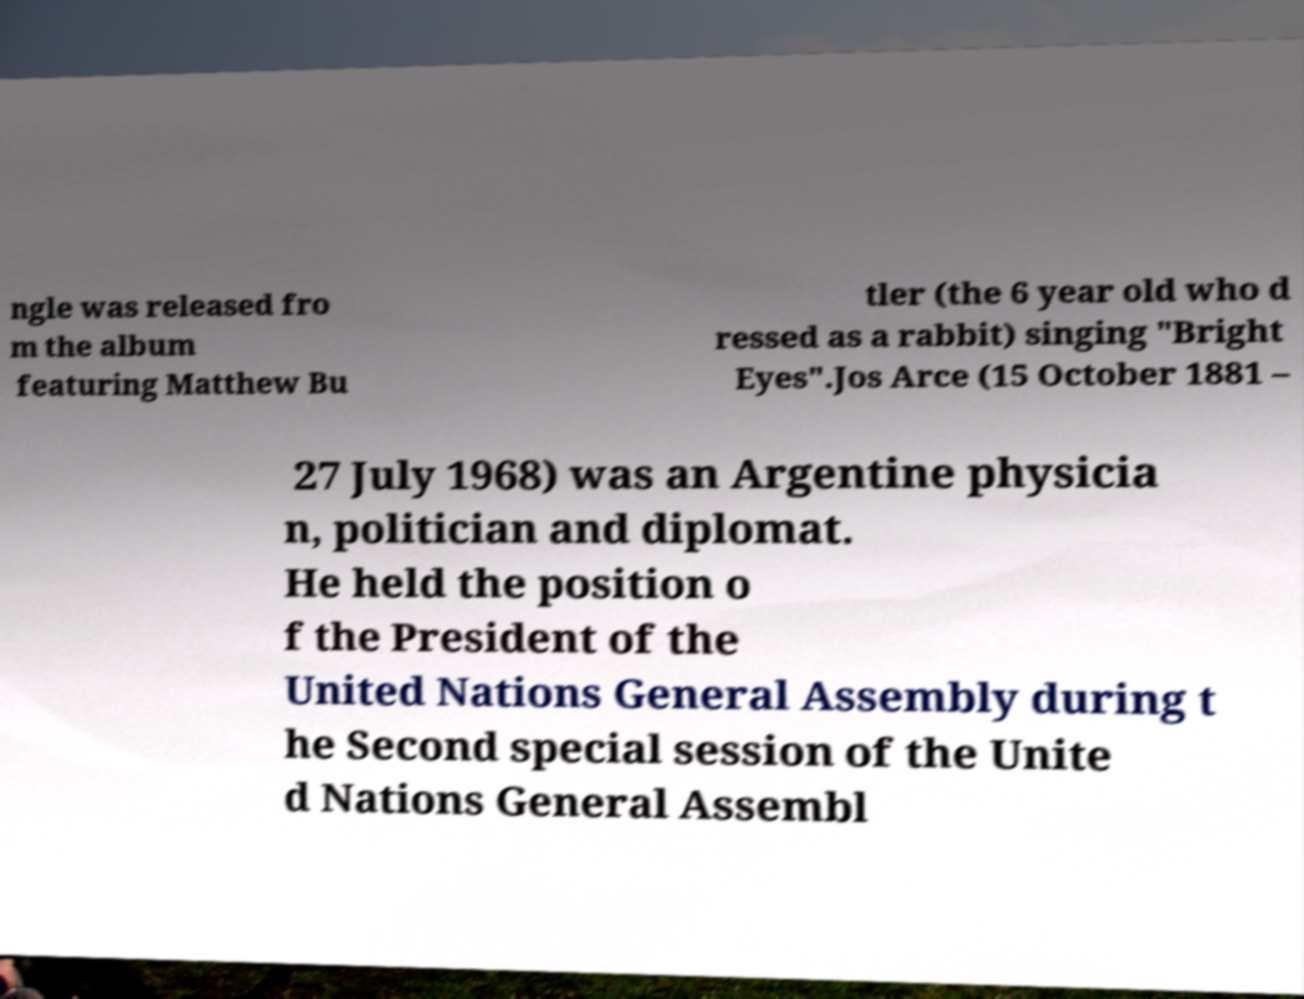Can you accurately transcribe the text from the provided image for me? ngle was released fro m the album featuring Matthew Bu tler (the 6 year old who d ressed as a rabbit) singing "Bright Eyes".Jos Arce (15 October 1881 – 27 July 1968) was an Argentine physicia n, politician and diplomat. He held the position o f the President of the United Nations General Assembly during t he Second special session of the Unite d Nations General Assembl 